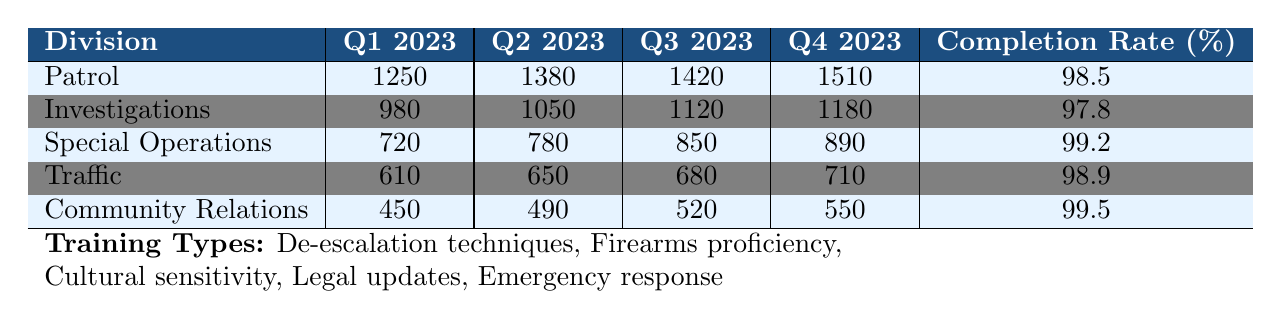What is the highest number of training hours completed by any division in Q4 2023? Looking at the "Q4 2023" column in the table, Patrol completed 1510 hours, which is the highest among all divisions for that quarter.
Answer: 1510 Which division has the lowest completion rate? From the completion rates provided, Investigations has a completion rate of 97.8%, which is the lowest when compared to the other divisions.
Answer: Investigations How many total training hours did the Community Relations division complete over all four quarters? The hours for Community Relations are: Q1 2023 (450) + Q2 2023 (490) + Q3 2023 (520) + Q4 2023 (550). Adding these together gives 450 + 490 + 520 + 550 = 2010 total training hours.
Answer: 2010 Did Special Operations complete more training hours in Q3 2023 than Traffic did in Q2 2023? The table shows Special Operations completed 850 hours in Q3 2023, while Traffic completed 650 hours in Q2 2023. Since 850 is more than 650, the statement is true.
Answer: Yes What is the average number of training hours completed by the Patrol division across all four quarters? The Patrol division completed 1250 (Q1) + 1380 (Q2) + 1420 (Q3) + 1510 (Q4) = 4560 hours in total over four quarters. To find the average, divide by 4, which is 4560 / 4 = 1140.
Answer: 1140 Which training type was likely given to all divisions, as suggested by their high completion rates? All divisions show high completion rates, especially the ones with rates above 98%. Likely, this suggests training types like De-escalation techniques or Emergency response that are critical for all divisions.
Answer: High completion rates indicate common training types How many more training hours did Investigations complete in Q3 compared to Q1? Investigations completed 1120 hours in Q3 and 980 hours in Q1. The difference is 1120 - 980 = 140 hours.
Answer: 140 Which division showed the smallest growth in training hours from Q1 to Q4? The total training hours for each division from Q1 to Q4 are: Patrol (1250 to 1510 = 260), Investigations (980 to 1180 = 200), Special Operations (720 to 890 = 170), Traffic (610 to 710 = 100), Community Relations (450 to 550 = 100). Community Relations and Traffic both show the smallest growth of 100 hours.
Answer: Traffic and Community Relations (100 hours each) What percentage of training hours did the Patrol division complete in Q2 compared to their Q1 training hours? In Q1, Patrol completed 1250 hours and in Q2, they completed 1380 hours. To find the percentage of Q2 compared to Q1: (1380 / 1250) * 100 = 110.4%.
Answer: 110.4% Which division had a consistent increase in training hours every quarter? By reviewing the training hours, Patrol, Investigations, Special Operations, Traffic, and Community Relations all show an increase from Q1 to Q4 without any decrease in between. This indicates they all experienced consistent growth.
Answer: All divisions showed consistent growth How does the completion rate of the Community Relations division compare to that of the Patrol division? Community Relations has a completion rate of 99.5%, while Patrol has a completion rate of 98.5%. Community Relations has a higher completion rate than Patrol by 1%.
Answer: Community Relations is higher by 1% 